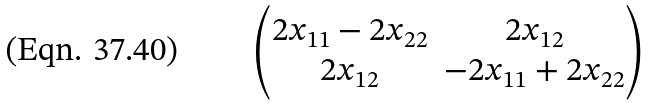Convert formula to latex. <formula><loc_0><loc_0><loc_500><loc_500>\begin{pmatrix} 2 { x } _ { 1 1 } - 2 { x } _ { 2 2 } & 2 { x } _ { 1 2 } \\ 2 { x } _ { 1 2 } & - 2 { x } _ { 1 1 } + 2 { x } _ { 2 2 } \\ \end{pmatrix}</formula> 